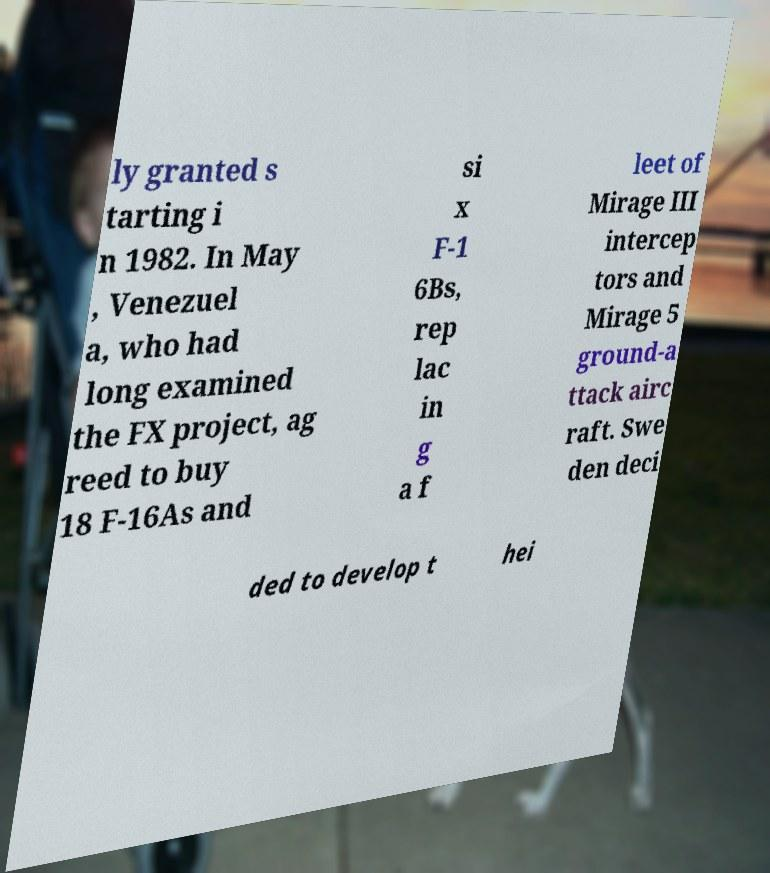Could you extract and type out the text from this image? ly granted s tarting i n 1982. In May , Venezuel a, who had long examined the FX project, ag reed to buy 18 F-16As and si x F-1 6Bs, rep lac in g a f leet of Mirage III intercep tors and Mirage 5 ground-a ttack airc raft. Swe den deci ded to develop t hei 